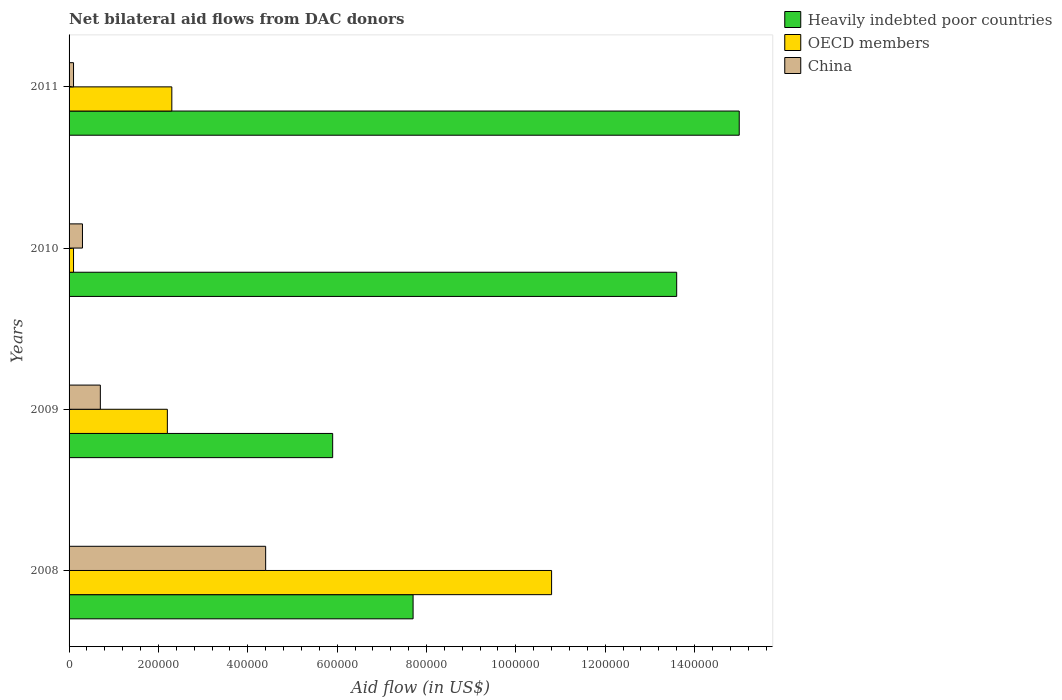How many groups of bars are there?
Your response must be concise. 4. Are the number of bars per tick equal to the number of legend labels?
Provide a short and direct response. Yes. How many bars are there on the 2nd tick from the bottom?
Ensure brevity in your answer.  3. In how many cases, is the number of bars for a given year not equal to the number of legend labels?
Offer a terse response. 0. What is the net bilateral aid flow in Heavily indebted poor countries in 2009?
Offer a very short reply. 5.90e+05. Across all years, what is the maximum net bilateral aid flow in Heavily indebted poor countries?
Keep it short and to the point. 1.50e+06. Across all years, what is the minimum net bilateral aid flow in Heavily indebted poor countries?
Provide a succinct answer. 5.90e+05. In which year was the net bilateral aid flow in OECD members maximum?
Provide a short and direct response. 2008. What is the total net bilateral aid flow in China in the graph?
Give a very brief answer. 5.50e+05. What is the difference between the net bilateral aid flow in Heavily indebted poor countries in 2008 and that in 2011?
Ensure brevity in your answer.  -7.30e+05. What is the difference between the net bilateral aid flow in China in 2009 and the net bilateral aid flow in Heavily indebted poor countries in 2008?
Give a very brief answer. -7.00e+05. What is the average net bilateral aid flow in China per year?
Your answer should be very brief. 1.38e+05. In the year 2008, what is the difference between the net bilateral aid flow in Heavily indebted poor countries and net bilateral aid flow in China?
Your answer should be compact. 3.30e+05. What is the difference between the highest and the second highest net bilateral aid flow in OECD members?
Ensure brevity in your answer.  8.50e+05. What is the difference between the highest and the lowest net bilateral aid flow in China?
Keep it short and to the point. 4.30e+05. In how many years, is the net bilateral aid flow in Heavily indebted poor countries greater than the average net bilateral aid flow in Heavily indebted poor countries taken over all years?
Ensure brevity in your answer.  2. Is the sum of the net bilateral aid flow in OECD members in 2009 and 2010 greater than the maximum net bilateral aid flow in Heavily indebted poor countries across all years?
Your response must be concise. No. What does the 3rd bar from the top in 2010 represents?
Your response must be concise. Heavily indebted poor countries. Is it the case that in every year, the sum of the net bilateral aid flow in Heavily indebted poor countries and net bilateral aid flow in China is greater than the net bilateral aid flow in OECD members?
Your answer should be very brief. Yes. How many bars are there?
Give a very brief answer. 12. How many years are there in the graph?
Your answer should be very brief. 4. Are the values on the major ticks of X-axis written in scientific E-notation?
Your response must be concise. No. Does the graph contain any zero values?
Keep it short and to the point. No. What is the title of the graph?
Give a very brief answer. Net bilateral aid flows from DAC donors. What is the label or title of the X-axis?
Ensure brevity in your answer.  Aid flow (in US$). What is the Aid flow (in US$) in Heavily indebted poor countries in 2008?
Keep it short and to the point. 7.70e+05. What is the Aid flow (in US$) in OECD members in 2008?
Provide a succinct answer. 1.08e+06. What is the Aid flow (in US$) of China in 2008?
Provide a succinct answer. 4.40e+05. What is the Aid flow (in US$) of Heavily indebted poor countries in 2009?
Your answer should be very brief. 5.90e+05. What is the Aid flow (in US$) of OECD members in 2009?
Give a very brief answer. 2.20e+05. What is the Aid flow (in US$) of China in 2009?
Keep it short and to the point. 7.00e+04. What is the Aid flow (in US$) in Heavily indebted poor countries in 2010?
Your response must be concise. 1.36e+06. What is the Aid flow (in US$) in China in 2010?
Your response must be concise. 3.00e+04. What is the Aid flow (in US$) in Heavily indebted poor countries in 2011?
Give a very brief answer. 1.50e+06. What is the Aid flow (in US$) in OECD members in 2011?
Your answer should be compact. 2.30e+05. What is the Aid flow (in US$) of China in 2011?
Give a very brief answer. 10000. Across all years, what is the maximum Aid flow (in US$) of Heavily indebted poor countries?
Offer a very short reply. 1.50e+06. Across all years, what is the maximum Aid flow (in US$) of OECD members?
Provide a short and direct response. 1.08e+06. Across all years, what is the minimum Aid flow (in US$) in Heavily indebted poor countries?
Your response must be concise. 5.90e+05. Across all years, what is the minimum Aid flow (in US$) of China?
Provide a short and direct response. 10000. What is the total Aid flow (in US$) of Heavily indebted poor countries in the graph?
Your response must be concise. 4.22e+06. What is the total Aid flow (in US$) of OECD members in the graph?
Your answer should be very brief. 1.54e+06. What is the difference between the Aid flow (in US$) of Heavily indebted poor countries in 2008 and that in 2009?
Ensure brevity in your answer.  1.80e+05. What is the difference between the Aid flow (in US$) of OECD members in 2008 and that in 2009?
Keep it short and to the point. 8.60e+05. What is the difference between the Aid flow (in US$) of Heavily indebted poor countries in 2008 and that in 2010?
Make the answer very short. -5.90e+05. What is the difference between the Aid flow (in US$) in OECD members in 2008 and that in 2010?
Offer a very short reply. 1.07e+06. What is the difference between the Aid flow (in US$) in Heavily indebted poor countries in 2008 and that in 2011?
Offer a very short reply. -7.30e+05. What is the difference between the Aid flow (in US$) in OECD members in 2008 and that in 2011?
Make the answer very short. 8.50e+05. What is the difference between the Aid flow (in US$) of China in 2008 and that in 2011?
Provide a short and direct response. 4.30e+05. What is the difference between the Aid flow (in US$) in Heavily indebted poor countries in 2009 and that in 2010?
Provide a succinct answer. -7.70e+05. What is the difference between the Aid flow (in US$) in China in 2009 and that in 2010?
Make the answer very short. 4.00e+04. What is the difference between the Aid flow (in US$) in Heavily indebted poor countries in 2009 and that in 2011?
Offer a very short reply. -9.10e+05. What is the difference between the Aid flow (in US$) of OECD members in 2009 and that in 2011?
Make the answer very short. -10000. What is the difference between the Aid flow (in US$) of OECD members in 2008 and the Aid flow (in US$) of China in 2009?
Offer a very short reply. 1.01e+06. What is the difference between the Aid flow (in US$) in Heavily indebted poor countries in 2008 and the Aid flow (in US$) in OECD members in 2010?
Offer a terse response. 7.60e+05. What is the difference between the Aid flow (in US$) of Heavily indebted poor countries in 2008 and the Aid flow (in US$) of China in 2010?
Your answer should be very brief. 7.40e+05. What is the difference between the Aid flow (in US$) in OECD members in 2008 and the Aid flow (in US$) in China in 2010?
Offer a very short reply. 1.05e+06. What is the difference between the Aid flow (in US$) in Heavily indebted poor countries in 2008 and the Aid flow (in US$) in OECD members in 2011?
Your answer should be compact. 5.40e+05. What is the difference between the Aid flow (in US$) of Heavily indebted poor countries in 2008 and the Aid flow (in US$) of China in 2011?
Make the answer very short. 7.60e+05. What is the difference between the Aid flow (in US$) of OECD members in 2008 and the Aid flow (in US$) of China in 2011?
Your answer should be very brief. 1.07e+06. What is the difference between the Aid flow (in US$) in Heavily indebted poor countries in 2009 and the Aid flow (in US$) in OECD members in 2010?
Offer a very short reply. 5.80e+05. What is the difference between the Aid flow (in US$) in Heavily indebted poor countries in 2009 and the Aid flow (in US$) in China in 2010?
Your answer should be very brief. 5.60e+05. What is the difference between the Aid flow (in US$) in OECD members in 2009 and the Aid flow (in US$) in China in 2010?
Keep it short and to the point. 1.90e+05. What is the difference between the Aid flow (in US$) of Heavily indebted poor countries in 2009 and the Aid flow (in US$) of China in 2011?
Give a very brief answer. 5.80e+05. What is the difference between the Aid flow (in US$) in Heavily indebted poor countries in 2010 and the Aid flow (in US$) in OECD members in 2011?
Offer a terse response. 1.13e+06. What is the difference between the Aid flow (in US$) of Heavily indebted poor countries in 2010 and the Aid flow (in US$) of China in 2011?
Offer a terse response. 1.35e+06. What is the average Aid flow (in US$) of Heavily indebted poor countries per year?
Provide a succinct answer. 1.06e+06. What is the average Aid flow (in US$) in OECD members per year?
Your answer should be very brief. 3.85e+05. What is the average Aid flow (in US$) in China per year?
Ensure brevity in your answer.  1.38e+05. In the year 2008, what is the difference between the Aid flow (in US$) of Heavily indebted poor countries and Aid flow (in US$) of OECD members?
Your answer should be very brief. -3.10e+05. In the year 2008, what is the difference between the Aid flow (in US$) of OECD members and Aid flow (in US$) of China?
Keep it short and to the point. 6.40e+05. In the year 2009, what is the difference between the Aid flow (in US$) of Heavily indebted poor countries and Aid flow (in US$) of OECD members?
Keep it short and to the point. 3.70e+05. In the year 2009, what is the difference between the Aid flow (in US$) in Heavily indebted poor countries and Aid flow (in US$) in China?
Your response must be concise. 5.20e+05. In the year 2010, what is the difference between the Aid flow (in US$) in Heavily indebted poor countries and Aid flow (in US$) in OECD members?
Offer a very short reply. 1.35e+06. In the year 2010, what is the difference between the Aid flow (in US$) in Heavily indebted poor countries and Aid flow (in US$) in China?
Provide a short and direct response. 1.33e+06. In the year 2011, what is the difference between the Aid flow (in US$) of Heavily indebted poor countries and Aid flow (in US$) of OECD members?
Provide a short and direct response. 1.27e+06. In the year 2011, what is the difference between the Aid flow (in US$) of Heavily indebted poor countries and Aid flow (in US$) of China?
Offer a terse response. 1.49e+06. What is the ratio of the Aid flow (in US$) of Heavily indebted poor countries in 2008 to that in 2009?
Offer a very short reply. 1.31. What is the ratio of the Aid flow (in US$) in OECD members in 2008 to that in 2009?
Give a very brief answer. 4.91. What is the ratio of the Aid flow (in US$) of China in 2008 to that in 2009?
Offer a terse response. 6.29. What is the ratio of the Aid flow (in US$) of Heavily indebted poor countries in 2008 to that in 2010?
Provide a succinct answer. 0.57. What is the ratio of the Aid flow (in US$) in OECD members in 2008 to that in 2010?
Your response must be concise. 108. What is the ratio of the Aid flow (in US$) of China in 2008 to that in 2010?
Your response must be concise. 14.67. What is the ratio of the Aid flow (in US$) of Heavily indebted poor countries in 2008 to that in 2011?
Offer a terse response. 0.51. What is the ratio of the Aid flow (in US$) of OECD members in 2008 to that in 2011?
Offer a terse response. 4.7. What is the ratio of the Aid flow (in US$) of Heavily indebted poor countries in 2009 to that in 2010?
Keep it short and to the point. 0.43. What is the ratio of the Aid flow (in US$) of China in 2009 to that in 2010?
Make the answer very short. 2.33. What is the ratio of the Aid flow (in US$) of Heavily indebted poor countries in 2009 to that in 2011?
Make the answer very short. 0.39. What is the ratio of the Aid flow (in US$) of OECD members in 2009 to that in 2011?
Keep it short and to the point. 0.96. What is the ratio of the Aid flow (in US$) of Heavily indebted poor countries in 2010 to that in 2011?
Your response must be concise. 0.91. What is the ratio of the Aid flow (in US$) in OECD members in 2010 to that in 2011?
Provide a succinct answer. 0.04. What is the ratio of the Aid flow (in US$) in China in 2010 to that in 2011?
Provide a short and direct response. 3. What is the difference between the highest and the second highest Aid flow (in US$) in Heavily indebted poor countries?
Your answer should be compact. 1.40e+05. What is the difference between the highest and the second highest Aid flow (in US$) of OECD members?
Your answer should be compact. 8.50e+05. What is the difference between the highest and the second highest Aid flow (in US$) of China?
Your answer should be very brief. 3.70e+05. What is the difference between the highest and the lowest Aid flow (in US$) in Heavily indebted poor countries?
Your response must be concise. 9.10e+05. What is the difference between the highest and the lowest Aid flow (in US$) in OECD members?
Your answer should be very brief. 1.07e+06. 